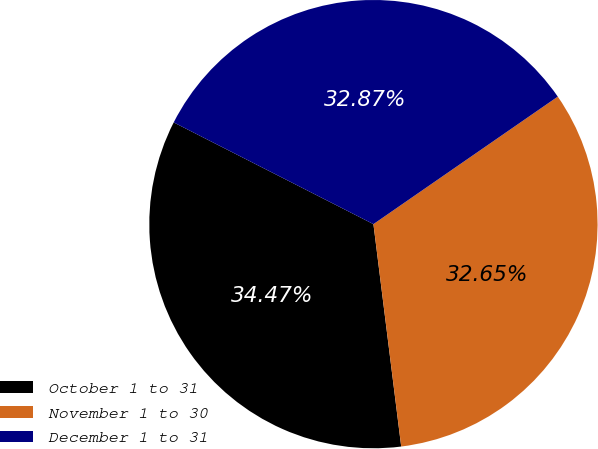Convert chart to OTSL. <chart><loc_0><loc_0><loc_500><loc_500><pie_chart><fcel>October 1 to 31<fcel>November 1 to 30<fcel>December 1 to 31<nl><fcel>34.47%<fcel>32.65%<fcel>32.87%<nl></chart> 